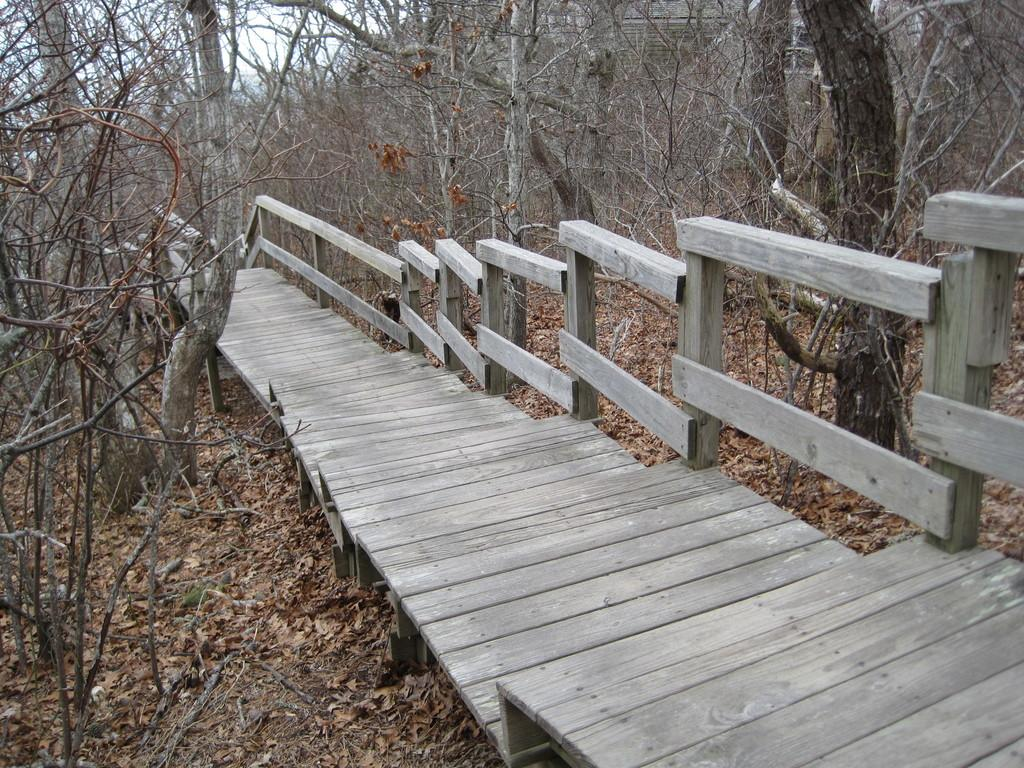What is the main structure in the center of the image? There is a bridge in the center of the image. What type of barrier can be seen in the image? There is a wooden fence in the image. What type of vegetation is present on both sides of the image? There are trees on the right side and trees on the left side of the image. What is the condition of the ground in the image? Dry grass is present in the image. What type of protest is taking place in the image? There is no protest present in the image; it features a bridge, a wooden fence, trees, and dry grass. How does the behavior of the bridge change throughout the image? The bridge does not exhibit any behavior, as it is an inanimate object. 